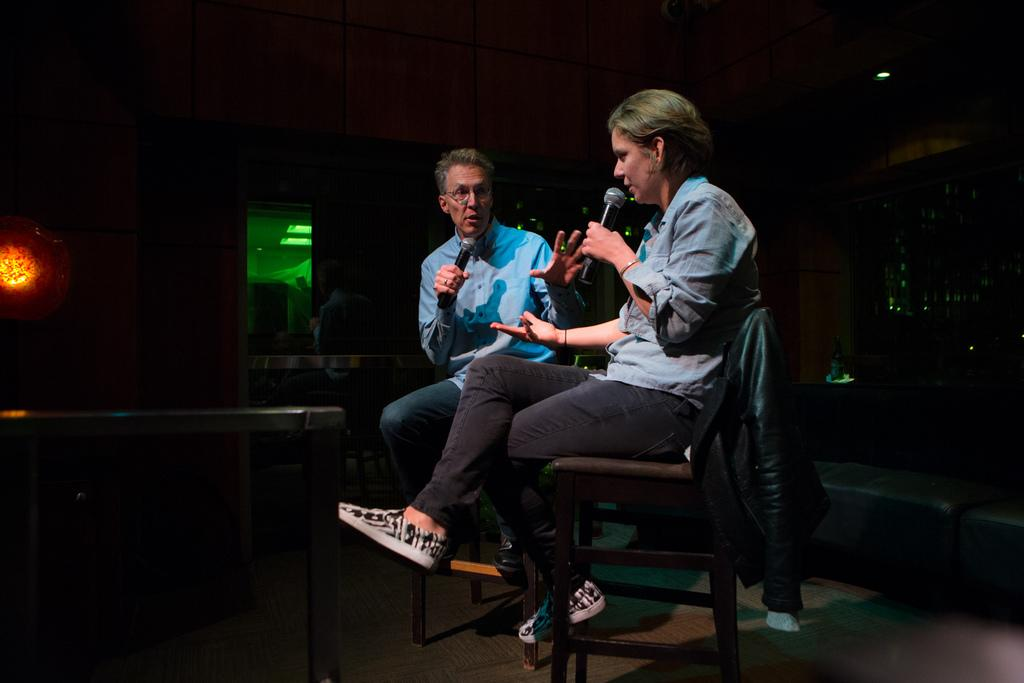How many people are in the image? There are two persons in the image. What are the persons doing in the image? The persons are sitting in chairs and speaking in front of a mic. What are the persons holding in their hands? The persons are holding a mic in their hands. What can be seen in the background of the image? There are other objects visible in the background of the image. What type of hammer is being used by the person in the image? There is no hammer present in the image. What kind of pipe can be seen in the background of the image? There is no pipe visible in the background of the image. 